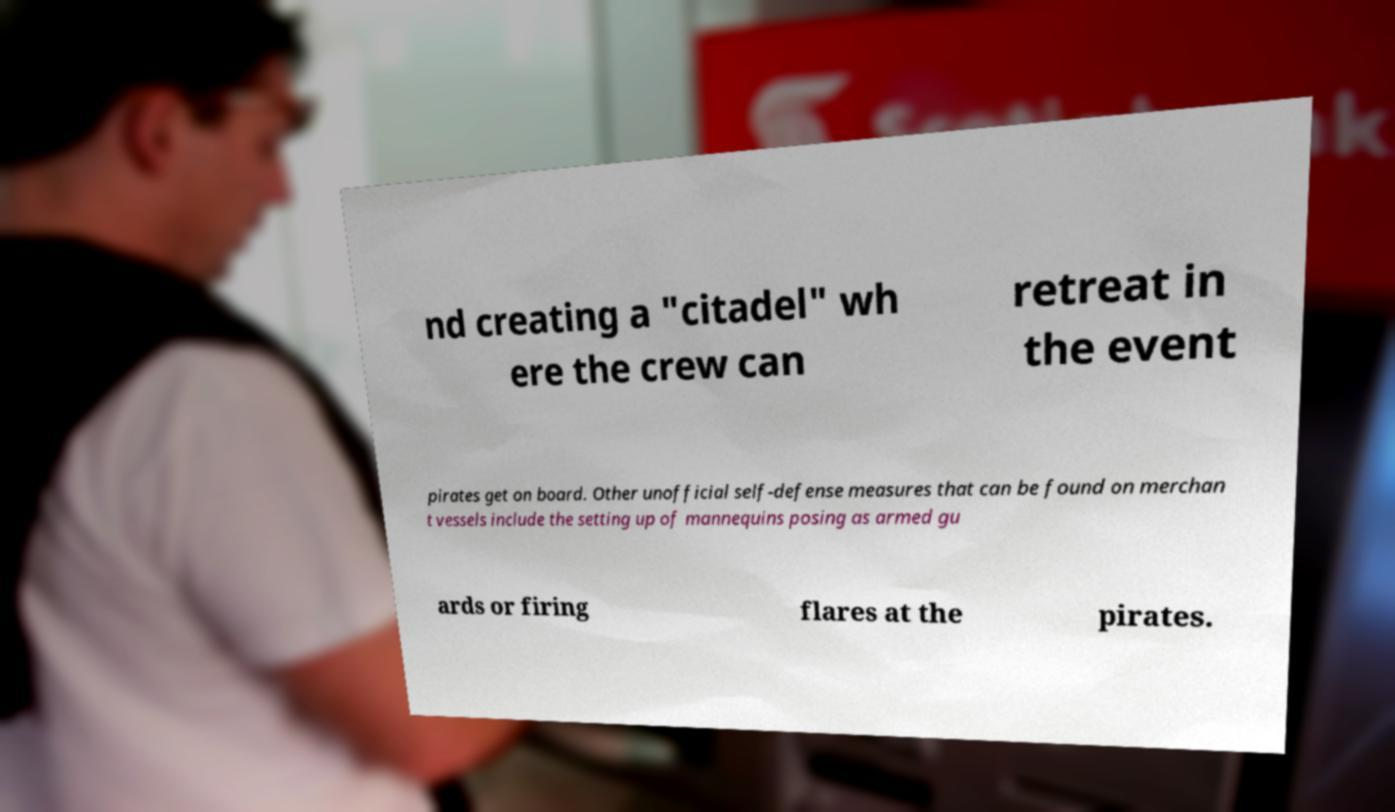Please identify and transcribe the text found in this image. nd creating a "citadel" wh ere the crew can retreat in the event pirates get on board. Other unofficial self-defense measures that can be found on merchan t vessels include the setting up of mannequins posing as armed gu ards or firing flares at the pirates. 